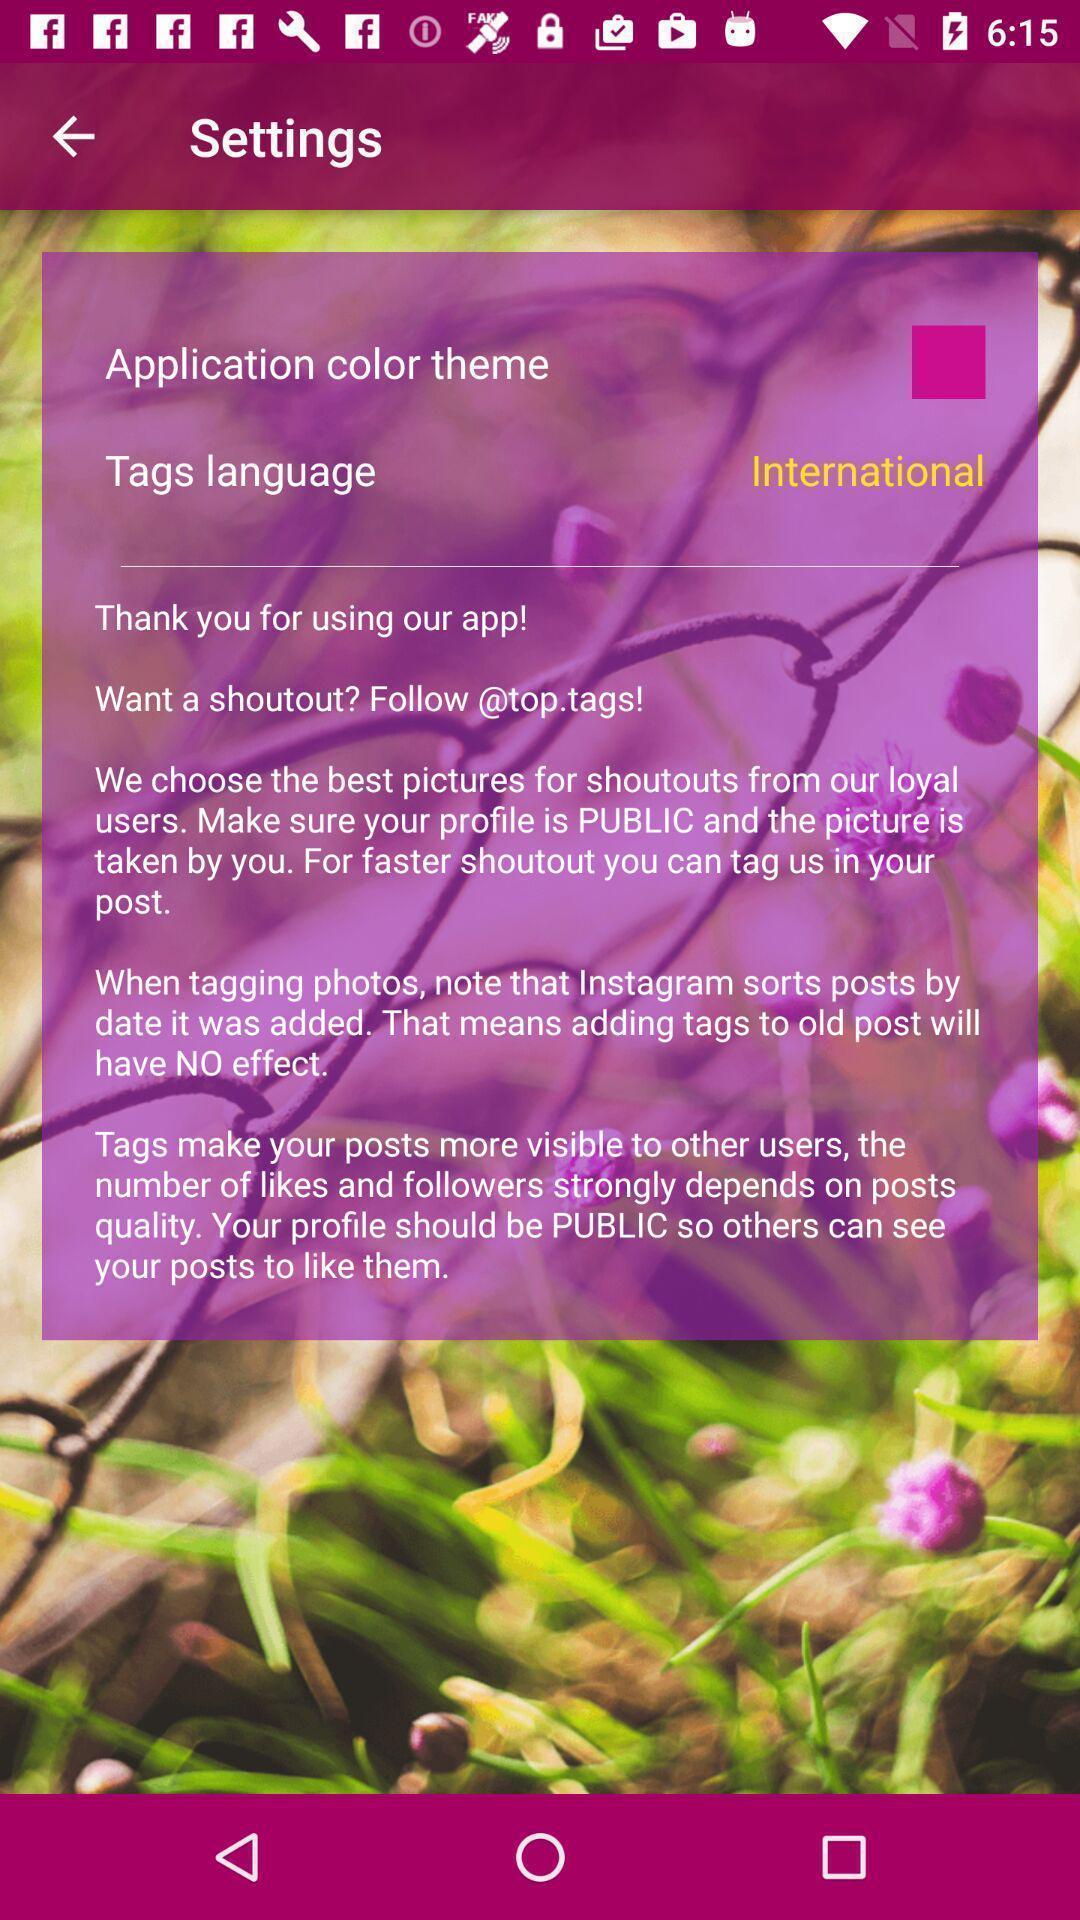What is the overall content of this screenshot? Settings page. 